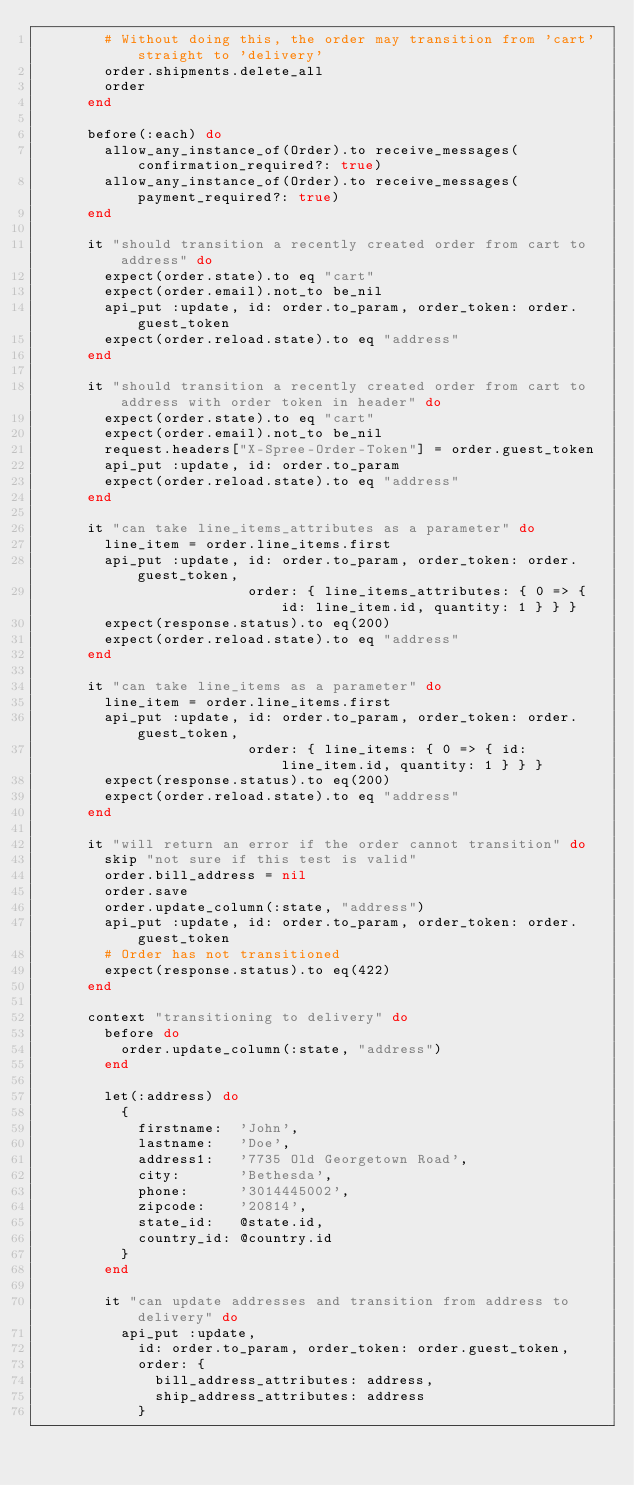Convert code to text. <code><loc_0><loc_0><loc_500><loc_500><_Ruby_>        # Without doing this, the order may transition from 'cart' straight to 'delivery'
        order.shipments.delete_all
        order
      end

      before(:each) do
        allow_any_instance_of(Order).to receive_messages(confirmation_required?: true)
        allow_any_instance_of(Order).to receive_messages(payment_required?: true)
      end

      it "should transition a recently created order from cart to address" do
        expect(order.state).to eq "cart"
        expect(order.email).not_to be_nil
        api_put :update, id: order.to_param, order_token: order.guest_token
        expect(order.reload.state).to eq "address"
      end

      it "should transition a recently created order from cart to address with order token in header" do
        expect(order.state).to eq "cart"
        expect(order.email).not_to be_nil
        request.headers["X-Spree-Order-Token"] = order.guest_token
        api_put :update, id: order.to_param
        expect(order.reload.state).to eq "address"
      end

      it "can take line_items_attributes as a parameter" do
        line_item = order.line_items.first
        api_put :update, id: order.to_param, order_token: order.guest_token,
                         order: { line_items_attributes: { 0 => { id: line_item.id, quantity: 1 } } }
        expect(response.status).to eq(200)
        expect(order.reload.state).to eq "address"
      end

      it "can take line_items as a parameter" do
        line_item = order.line_items.first
        api_put :update, id: order.to_param, order_token: order.guest_token,
                         order: { line_items: { 0 => { id: line_item.id, quantity: 1 } } }
        expect(response.status).to eq(200)
        expect(order.reload.state).to eq "address"
      end

      it "will return an error if the order cannot transition" do
        skip "not sure if this test is valid"
        order.bill_address = nil
        order.save
        order.update_column(:state, "address")
        api_put :update, id: order.to_param, order_token: order.guest_token
        # Order has not transitioned
        expect(response.status).to eq(422)
      end

      context "transitioning to delivery" do
        before do
          order.update_column(:state, "address")
        end

        let(:address) do
          {
            firstname:  'John',
            lastname:   'Doe',
            address1:   '7735 Old Georgetown Road',
            city:       'Bethesda',
            phone:      '3014445002',
            zipcode:    '20814',
            state_id:   @state.id,
            country_id: @country.id
          }
        end

        it "can update addresses and transition from address to delivery" do
          api_put :update,
            id: order.to_param, order_token: order.guest_token,
            order: {
              bill_address_attributes: address,
              ship_address_attributes: address
            }</code> 